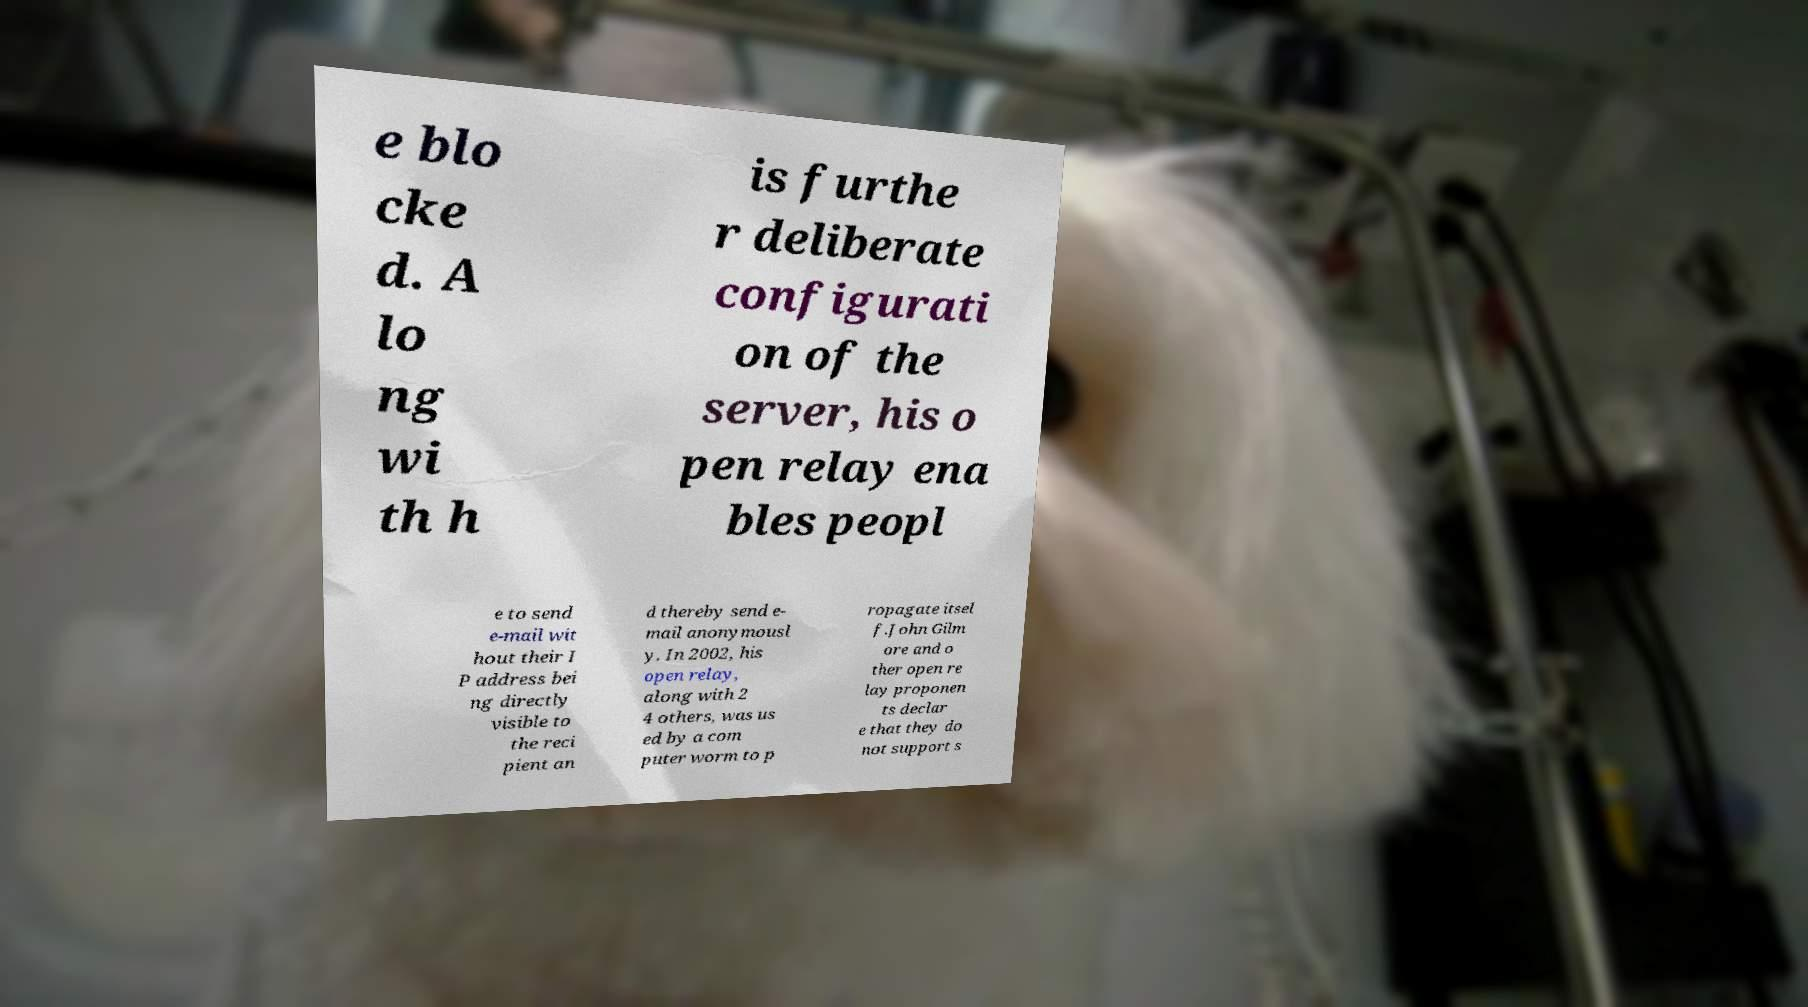There's text embedded in this image that I need extracted. Can you transcribe it verbatim? e blo cke d. A lo ng wi th h is furthe r deliberate configurati on of the server, his o pen relay ena bles peopl e to send e-mail wit hout their I P address bei ng directly visible to the reci pient an d thereby send e- mail anonymousl y. In 2002, his open relay, along with 2 4 others, was us ed by a com puter worm to p ropagate itsel f.John Gilm ore and o ther open re lay proponen ts declar e that they do not support s 